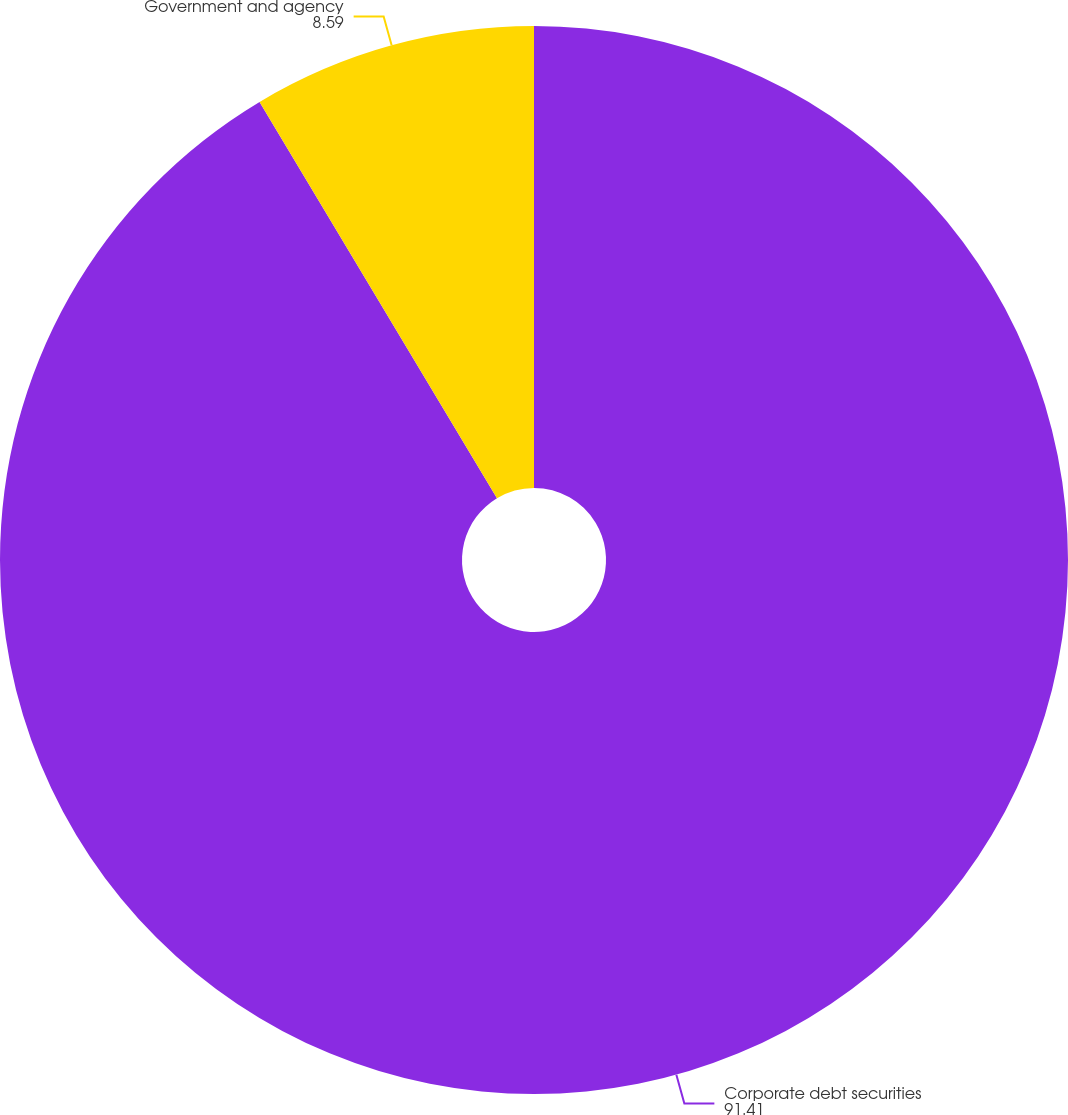Convert chart to OTSL. <chart><loc_0><loc_0><loc_500><loc_500><pie_chart><fcel>Corporate debt securities<fcel>Government and agency<nl><fcel>91.41%<fcel>8.59%<nl></chart> 